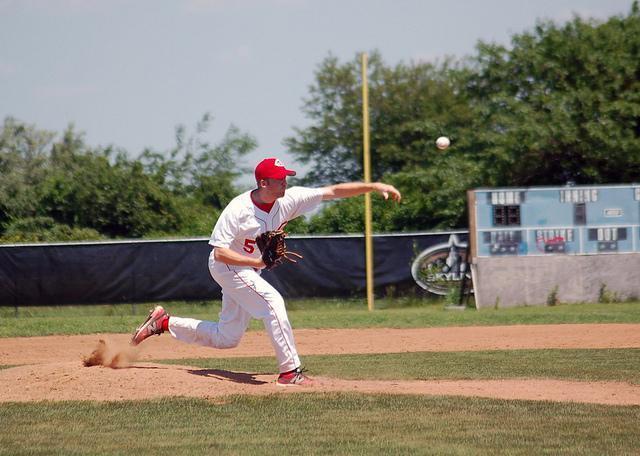How many carrots are in the bowls?
Give a very brief answer. 0. 